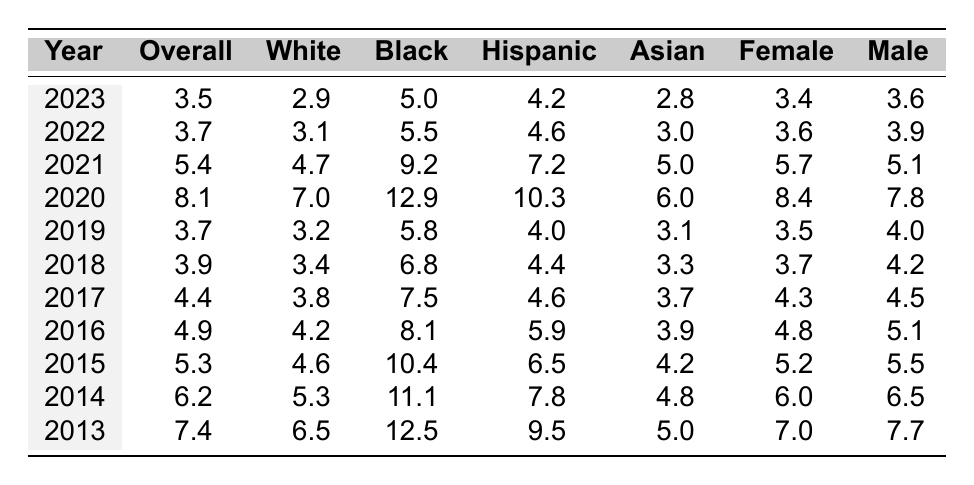What was the overall unemployment rate in 2020? The table shows the value for the overall unemployment rate in 2020, which is directly listed as 8.1.
Answer: 8.1 Which demographic group had the highest unemployment rate in 2013? By looking at the values for 2013 in the table, the black demographic group has the highest unemployment rate at 12.5.
Answer: Black: 12.5 What is the difference in unemployment rates between males and females in 2021? In 2021, the unemployment rate for males is 5.1 and for females is 5.7. The difference is calculated as 5.7 - 5.1 = 0.6.
Answer: 0.6 What was the average unemployment rate for the Asian demographic group over the past decade? The values for the Asian demographic group over the decade are: 5.0, 4.8, 4.2, 3.9, 3.7, 3.3, 3.1, 6.0, 5.0, and 2.8. Summing these gives 43.0. Dividing by 10 gives the average of 4.3.
Answer: 4.3 Which demographic had the lowest unemployment rate in 2023? In 2023, the unemployment rates for each demographic are: white (2.9), black (5.0), hispanic (4.2), asian (2.8), female (3.4), male (3.6). The lowest rate is for the Asian demographic at 2.8.
Answer: Asian: 2.8 In which year did the overall unemployment rate first fall below 4%? The table shows unemployment rates for each year; the first instance where the overall rate falls below 4% is in 2018, which recorded 3.9.
Answer: 2018 What was the trend in the unemployment rate for females from 2013 to 2023? Checking the female unemployment rates from 2013 (7.0), 2014 (6.0), 2015 (5.2), 2016 (4.8), 2017 (4.3), 2018 (3.7), 2019 (3.5), 2020 (8.4), 2021 (5.7), 2022 (3.6), to 2023 (3.4), the trend generally shows a decrease with an increase in 2020.
Answer: Generally decreasing with 2020 spike True or False: The unemployment rate for Black individuals was higher than that of Hispanic individuals in every year of the decade. By comparing the rates from the table, in 2013, 2014, 2015, 2016, 2017, and 2021 black unemployment rates are consistently higher than hispanic unemployment rates. However, from 2021 onwards, Hispanic rates are lower than Black. Thus, the statement is false.
Answer: False What was the overall unemployment rate change from 2013 to 2023? The overall unemployment rate in 2013 is 7.4, and in 2023 it is 3.5. The change can be calculated as 3.5 - 7.4 = -3.9, indicating a decrease.
Answer: Decrease of 3.9 